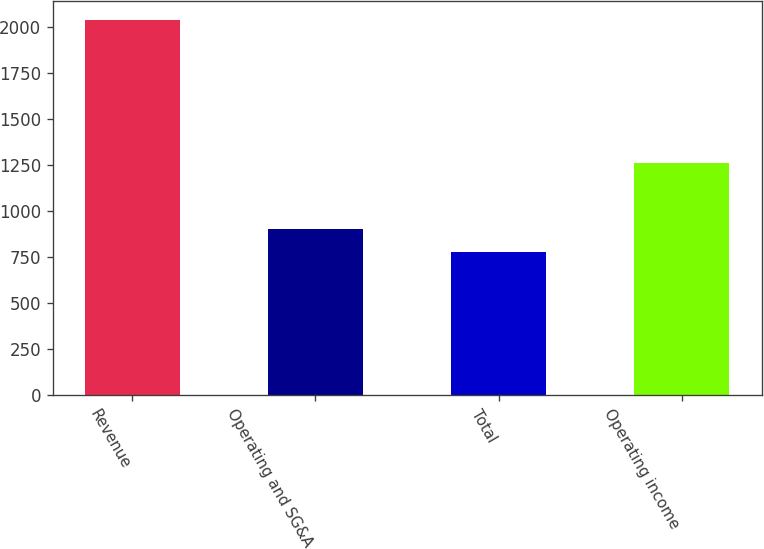Convert chart to OTSL. <chart><loc_0><loc_0><loc_500><loc_500><bar_chart><fcel>Revenue<fcel>Operating and SG&A<fcel>Total<fcel>Operating income<nl><fcel>2037.1<fcel>903.55<fcel>777.6<fcel>1259.5<nl></chart> 